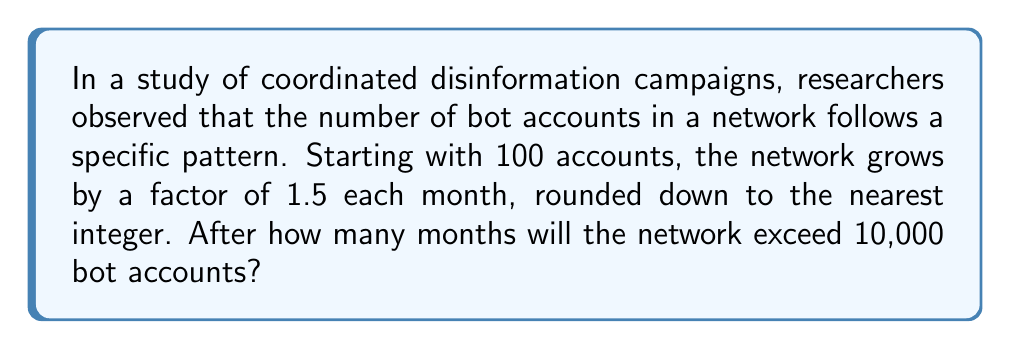Help me with this question. Let's approach this step-by-step:

1) We start with 100 accounts and multiply by 1.5 each month, rounding down.

2) Let's calculate the number of accounts for each month:

   Month 0: 100
   Month 1: $\lfloor 100 \times 1.5 \rfloor = 150$
   Month 2: $\lfloor 150 \times 1.5 \rfloor = 225$
   Month 3: $\lfloor 225 \times 1.5 \rfloor = 337$
   Month 4: $\lfloor 337 \times 1.5 \rfloor = 505$
   Month 5: $\lfloor 505 \times 1.5 \rfloor = 757$
   Month 6: $\lfloor 757 \times 1.5 \rfloor = 1,135$
   Month 7: $\lfloor 1,135 \times 1.5 \rfloor = 1,702$
   Month 8: $\lfloor 1,702 \times 1.5 \rfloor = 2,553$
   Month 9: $\lfloor 2,553 \times 1.5 \rfloor = 3,829$
   Month 10: $\lfloor 3,829 \times 1.5 \rfloor = 5,743$
   Month 11: $\lfloor 5,743 \times 1.5 \rfloor = 8,614$
   Month 12: $\lfloor 8,614 \times 1.5 \rfloor = 12,921$

3) We can see that after 12 months, the number of bot accounts exceeds 10,000 for the first time.

This growth pattern reveals how quickly disinformation networks can expand, highlighting the challenges in combating such coordinated campaigns.
Answer: 12 months 